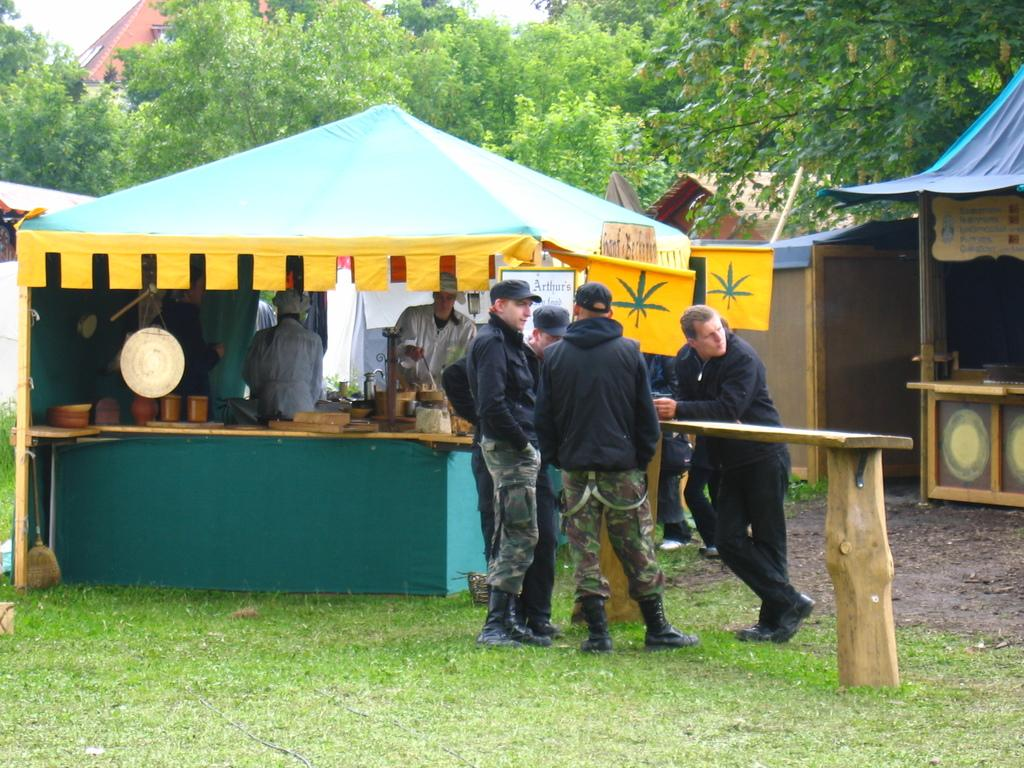What type of seating is visible in the image? There are persons at a wooden bench in the image. What type of ground is visible at the bottom of the image? There is grass at the bottom of the image. What structures can be seen in the background of the image? There is a tent, persons, huts, trees, buildings, and the sky visible in the background of the image. What type of curve can be seen in the image? There is no curve present in the image. The image features a wooden bench, grass, a tent, persons, huts, trees, buildings, and the sky in the background, but no curve. 